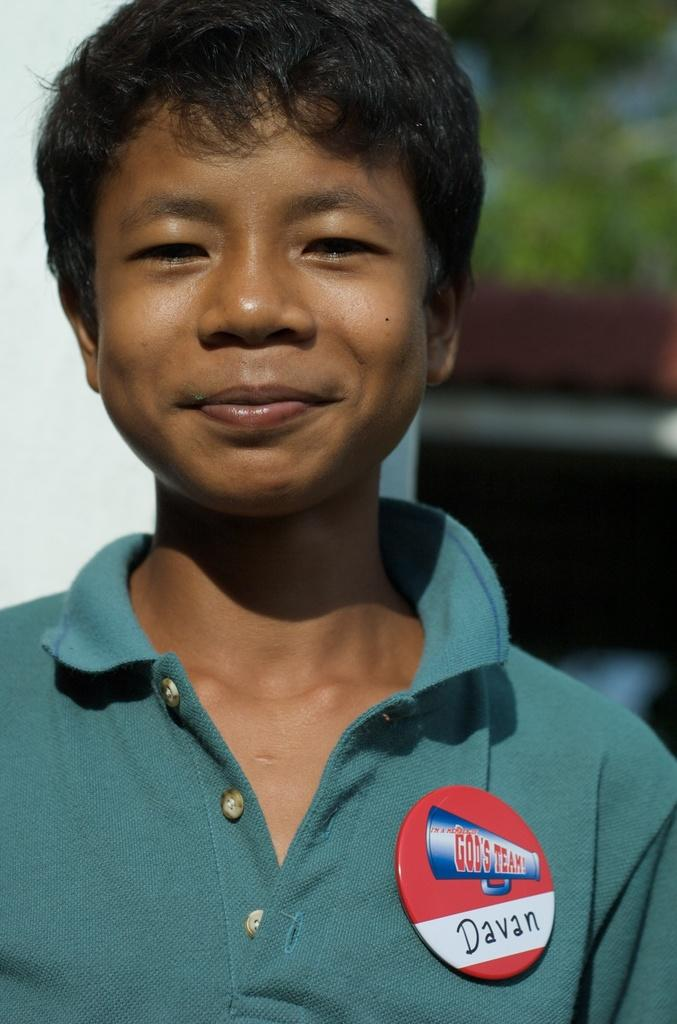What is the main subject of the image? The main subject of the image is a boy. What is the boy's facial expression in the image? The boy is smiling in the image. Can you describe any additional details about the boy's appearance? The boy has a badge on his shirt. What type of game is the boy playing in the image? There is no game visible in the image; it only shows a boy smiling with a badge on his shirt. How many wings can be seen on the boy in the image? The boy does not have any wings in the image. 